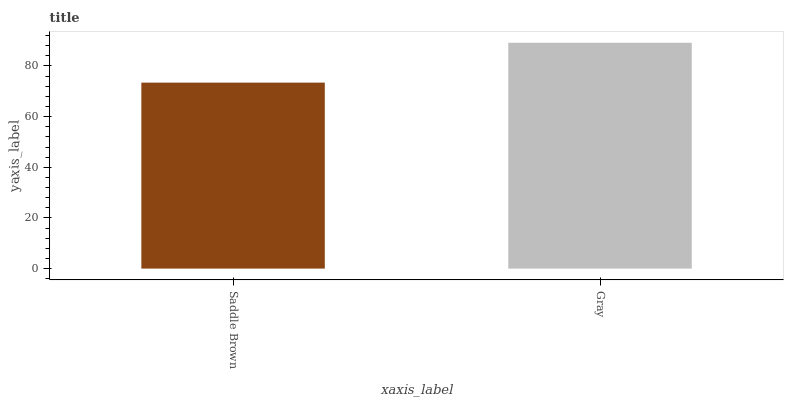Is Saddle Brown the minimum?
Answer yes or no. Yes. Is Gray the maximum?
Answer yes or no. Yes. Is Gray the minimum?
Answer yes or no. No. Is Gray greater than Saddle Brown?
Answer yes or no. Yes. Is Saddle Brown less than Gray?
Answer yes or no. Yes. Is Saddle Brown greater than Gray?
Answer yes or no. No. Is Gray less than Saddle Brown?
Answer yes or no. No. Is Gray the high median?
Answer yes or no. Yes. Is Saddle Brown the low median?
Answer yes or no. Yes. Is Saddle Brown the high median?
Answer yes or no. No. Is Gray the low median?
Answer yes or no. No. 